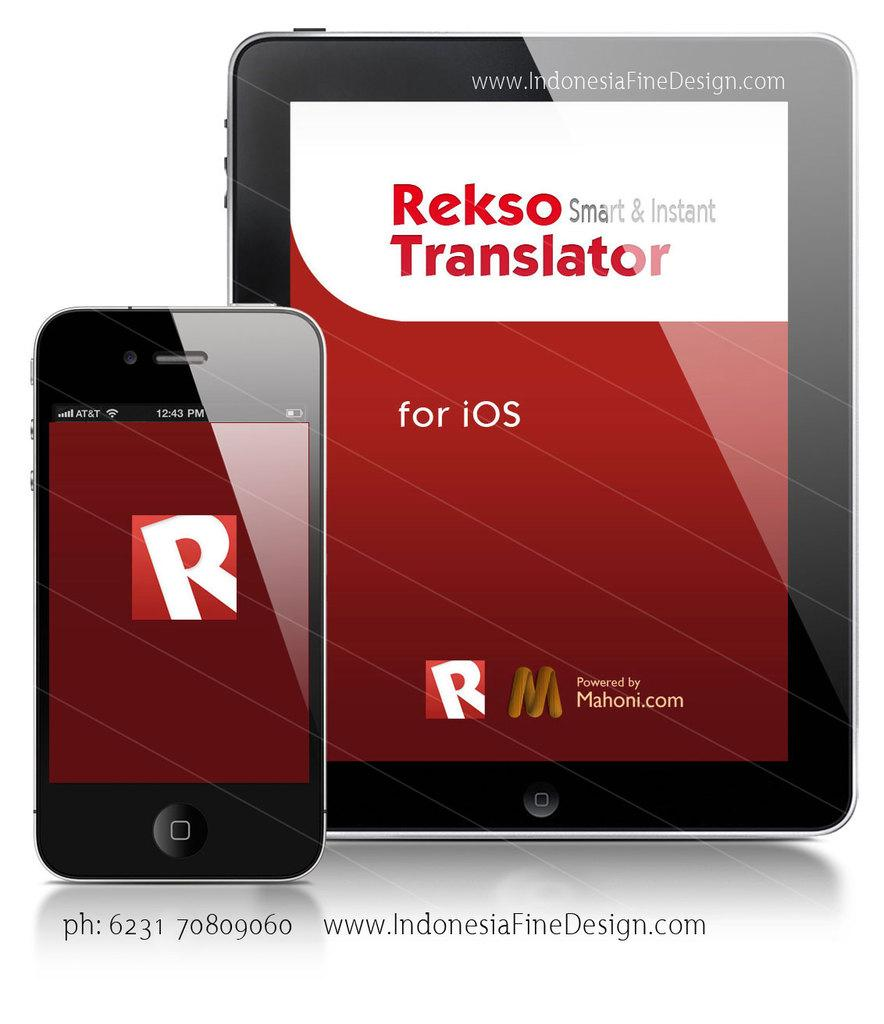<image>
Share a concise interpretation of the image provided. A phone and tablet are displayed, advertising Rekso Translator for iOS, powered by Mahoni.com. 